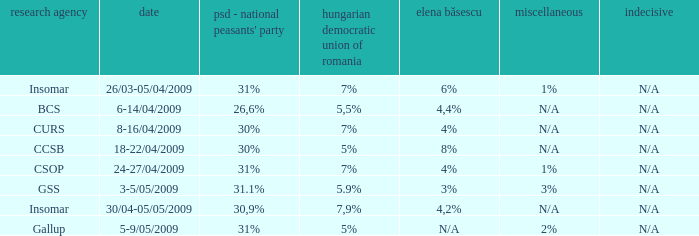What is the psd-pc for 18-22/04/2009? 30%. 